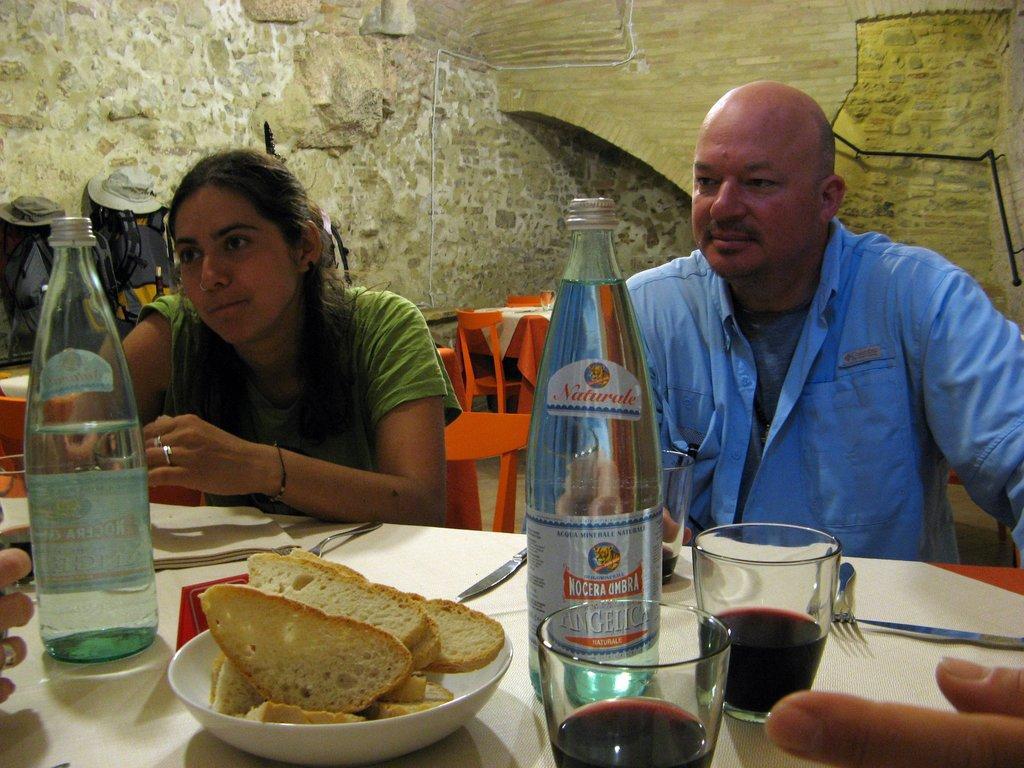In one or two sentences, can you explain what this image depicts? There are two persons are sitting on a chairs. There is a table. There is a bottle,glass ,bowl,biscuits,tissues on a table. There is another table in the center. We can see in the background wall. 